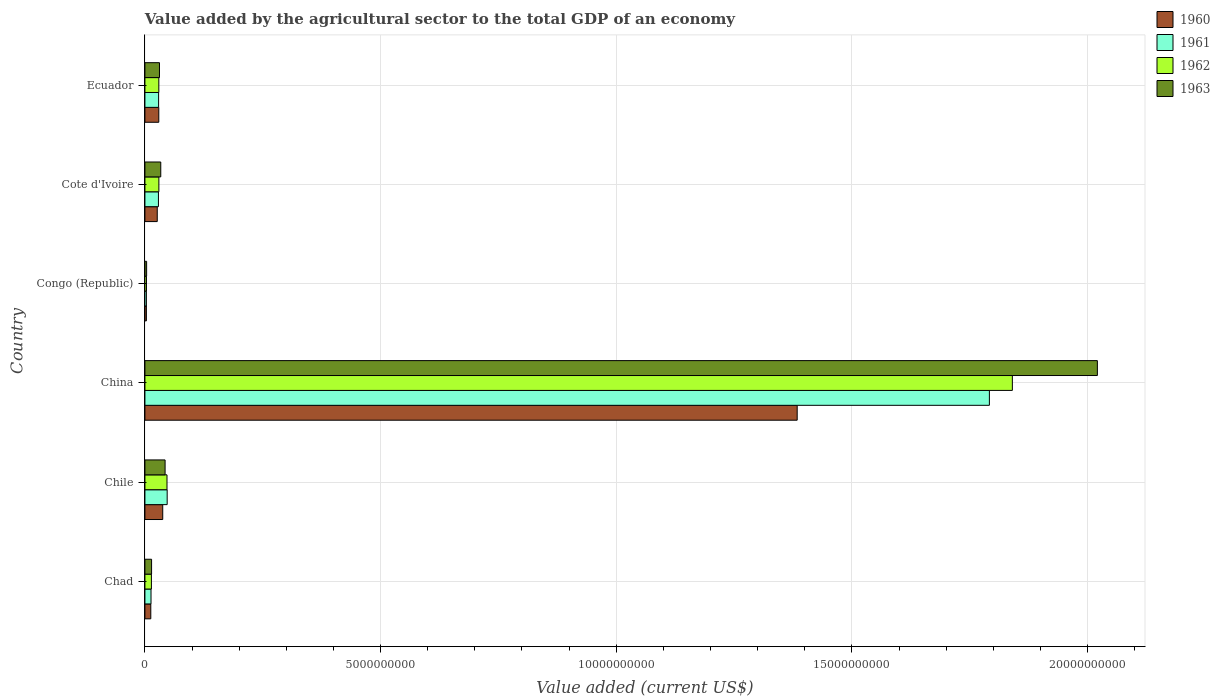How many groups of bars are there?
Your response must be concise. 6. Are the number of bars per tick equal to the number of legend labels?
Your response must be concise. Yes. Are the number of bars on each tick of the Y-axis equal?
Provide a short and direct response. Yes. What is the label of the 4th group of bars from the top?
Provide a succinct answer. China. What is the value added by the agricultural sector to the total GDP in 1963 in Chad?
Ensure brevity in your answer.  1.41e+08. Across all countries, what is the maximum value added by the agricultural sector to the total GDP in 1962?
Provide a succinct answer. 1.84e+1. Across all countries, what is the minimum value added by the agricultural sector to the total GDP in 1960?
Your answer should be very brief. 3.11e+07. In which country was the value added by the agricultural sector to the total GDP in 1960 maximum?
Your answer should be very brief. China. In which country was the value added by the agricultural sector to the total GDP in 1960 minimum?
Ensure brevity in your answer.  Congo (Republic). What is the total value added by the agricultural sector to the total GDP in 1962 in the graph?
Keep it short and to the point. 1.96e+1. What is the difference between the value added by the agricultural sector to the total GDP in 1962 in Chad and that in Congo (Republic)?
Provide a succinct answer. 1.05e+08. What is the difference between the value added by the agricultural sector to the total GDP in 1963 in Chad and the value added by the agricultural sector to the total GDP in 1961 in Congo (Republic)?
Your answer should be very brief. 1.10e+08. What is the average value added by the agricultural sector to the total GDP in 1961 per country?
Ensure brevity in your answer.  3.19e+09. What is the difference between the value added by the agricultural sector to the total GDP in 1961 and value added by the agricultural sector to the total GDP in 1960 in Chad?
Your answer should be compact. 4.82e+06. In how many countries, is the value added by the agricultural sector to the total GDP in 1962 greater than 19000000000 US$?
Offer a terse response. 0. What is the ratio of the value added by the agricultural sector to the total GDP in 1961 in Chile to that in Congo (Republic)?
Your response must be concise. 15.19. Is the value added by the agricultural sector to the total GDP in 1962 in Chile less than that in Ecuador?
Your answer should be very brief. No. Is the difference between the value added by the agricultural sector to the total GDP in 1961 in Chad and Cote d'Ivoire greater than the difference between the value added by the agricultural sector to the total GDP in 1960 in Chad and Cote d'Ivoire?
Offer a terse response. No. What is the difference between the highest and the second highest value added by the agricultural sector to the total GDP in 1962?
Make the answer very short. 1.79e+1. What is the difference between the highest and the lowest value added by the agricultural sector to the total GDP in 1963?
Keep it short and to the point. 2.02e+1. In how many countries, is the value added by the agricultural sector to the total GDP in 1960 greater than the average value added by the agricultural sector to the total GDP in 1960 taken over all countries?
Give a very brief answer. 1. What does the 4th bar from the bottom in Cote d'Ivoire represents?
Ensure brevity in your answer.  1963. How many bars are there?
Your response must be concise. 24. Are all the bars in the graph horizontal?
Keep it short and to the point. Yes. How many countries are there in the graph?
Keep it short and to the point. 6. What is the title of the graph?
Keep it short and to the point. Value added by the agricultural sector to the total GDP of an economy. Does "1999" appear as one of the legend labels in the graph?
Your answer should be very brief. No. What is the label or title of the X-axis?
Your response must be concise. Value added (current US$). What is the Value added (current US$) of 1960 in Chad?
Keep it short and to the point. 1.25e+08. What is the Value added (current US$) of 1961 in Chad?
Keep it short and to the point. 1.29e+08. What is the Value added (current US$) of 1962 in Chad?
Your answer should be compact. 1.38e+08. What is the Value added (current US$) in 1963 in Chad?
Your answer should be compact. 1.41e+08. What is the Value added (current US$) in 1960 in Chile?
Give a very brief answer. 3.78e+08. What is the Value added (current US$) in 1961 in Chile?
Provide a succinct answer. 4.72e+08. What is the Value added (current US$) of 1962 in Chile?
Give a very brief answer. 4.69e+08. What is the Value added (current US$) of 1963 in Chile?
Make the answer very short. 4.28e+08. What is the Value added (current US$) of 1960 in China?
Your answer should be very brief. 1.38e+1. What is the Value added (current US$) of 1961 in China?
Keep it short and to the point. 1.79e+1. What is the Value added (current US$) of 1962 in China?
Provide a succinct answer. 1.84e+1. What is the Value added (current US$) of 1963 in China?
Your answer should be compact. 2.02e+1. What is the Value added (current US$) in 1960 in Congo (Republic)?
Your answer should be compact. 3.11e+07. What is the Value added (current US$) in 1961 in Congo (Republic)?
Provide a succinct answer. 3.11e+07. What is the Value added (current US$) of 1962 in Congo (Republic)?
Ensure brevity in your answer.  3.30e+07. What is the Value added (current US$) in 1963 in Congo (Republic)?
Ensure brevity in your answer.  3.61e+07. What is the Value added (current US$) in 1960 in Cote d'Ivoire?
Give a very brief answer. 2.62e+08. What is the Value added (current US$) in 1961 in Cote d'Ivoire?
Provide a short and direct response. 2.87e+08. What is the Value added (current US$) in 1962 in Cote d'Ivoire?
Your answer should be very brief. 2.96e+08. What is the Value added (current US$) in 1963 in Cote d'Ivoire?
Your answer should be compact. 3.36e+08. What is the Value added (current US$) of 1960 in Ecuador?
Offer a very short reply. 2.94e+08. What is the Value added (current US$) in 1961 in Ecuador?
Offer a very short reply. 2.91e+08. What is the Value added (current US$) of 1962 in Ecuador?
Your answer should be very brief. 2.95e+08. What is the Value added (current US$) of 1963 in Ecuador?
Provide a succinct answer. 3.09e+08. Across all countries, what is the maximum Value added (current US$) in 1960?
Provide a succinct answer. 1.38e+1. Across all countries, what is the maximum Value added (current US$) of 1961?
Ensure brevity in your answer.  1.79e+1. Across all countries, what is the maximum Value added (current US$) of 1962?
Your response must be concise. 1.84e+1. Across all countries, what is the maximum Value added (current US$) of 1963?
Provide a succinct answer. 2.02e+1. Across all countries, what is the minimum Value added (current US$) in 1960?
Provide a short and direct response. 3.11e+07. Across all countries, what is the minimum Value added (current US$) in 1961?
Offer a terse response. 3.11e+07. Across all countries, what is the minimum Value added (current US$) of 1962?
Make the answer very short. 3.30e+07. Across all countries, what is the minimum Value added (current US$) in 1963?
Keep it short and to the point. 3.61e+07. What is the total Value added (current US$) in 1960 in the graph?
Your answer should be very brief. 1.49e+1. What is the total Value added (current US$) of 1961 in the graph?
Provide a short and direct response. 1.91e+1. What is the total Value added (current US$) in 1962 in the graph?
Offer a very short reply. 1.96e+1. What is the total Value added (current US$) of 1963 in the graph?
Keep it short and to the point. 2.15e+1. What is the difference between the Value added (current US$) of 1960 in Chad and that in Chile?
Offer a very short reply. -2.54e+08. What is the difference between the Value added (current US$) in 1961 in Chad and that in Chile?
Your answer should be very brief. -3.43e+08. What is the difference between the Value added (current US$) in 1962 in Chad and that in Chile?
Keep it short and to the point. -3.31e+08. What is the difference between the Value added (current US$) of 1963 in Chad and that in Chile?
Offer a terse response. -2.87e+08. What is the difference between the Value added (current US$) in 1960 in Chad and that in China?
Your response must be concise. -1.37e+1. What is the difference between the Value added (current US$) in 1961 in Chad and that in China?
Offer a very short reply. -1.78e+1. What is the difference between the Value added (current US$) of 1962 in Chad and that in China?
Provide a succinct answer. -1.83e+1. What is the difference between the Value added (current US$) in 1963 in Chad and that in China?
Your answer should be very brief. -2.01e+1. What is the difference between the Value added (current US$) of 1960 in Chad and that in Congo (Republic)?
Give a very brief answer. 9.35e+07. What is the difference between the Value added (current US$) in 1961 in Chad and that in Congo (Republic)?
Your response must be concise. 9.83e+07. What is the difference between the Value added (current US$) in 1962 in Chad and that in Congo (Republic)?
Keep it short and to the point. 1.05e+08. What is the difference between the Value added (current US$) of 1963 in Chad and that in Congo (Republic)?
Your answer should be very brief. 1.05e+08. What is the difference between the Value added (current US$) of 1960 in Chad and that in Cote d'Ivoire?
Provide a short and direct response. -1.37e+08. What is the difference between the Value added (current US$) in 1961 in Chad and that in Cote d'Ivoire?
Ensure brevity in your answer.  -1.58e+08. What is the difference between the Value added (current US$) in 1962 in Chad and that in Cote d'Ivoire?
Your response must be concise. -1.59e+08. What is the difference between the Value added (current US$) in 1963 in Chad and that in Cote d'Ivoire?
Offer a very short reply. -1.95e+08. What is the difference between the Value added (current US$) in 1960 in Chad and that in Ecuador?
Give a very brief answer. -1.70e+08. What is the difference between the Value added (current US$) of 1961 in Chad and that in Ecuador?
Provide a succinct answer. -1.61e+08. What is the difference between the Value added (current US$) in 1962 in Chad and that in Ecuador?
Ensure brevity in your answer.  -1.58e+08. What is the difference between the Value added (current US$) of 1963 in Chad and that in Ecuador?
Keep it short and to the point. -1.68e+08. What is the difference between the Value added (current US$) in 1960 in Chile and that in China?
Keep it short and to the point. -1.35e+1. What is the difference between the Value added (current US$) in 1961 in Chile and that in China?
Ensure brevity in your answer.  -1.74e+1. What is the difference between the Value added (current US$) in 1962 in Chile and that in China?
Your answer should be very brief. -1.79e+1. What is the difference between the Value added (current US$) of 1963 in Chile and that in China?
Your answer should be compact. -1.98e+1. What is the difference between the Value added (current US$) of 1960 in Chile and that in Congo (Republic)?
Your response must be concise. 3.47e+08. What is the difference between the Value added (current US$) of 1961 in Chile and that in Congo (Republic)?
Your answer should be compact. 4.41e+08. What is the difference between the Value added (current US$) in 1962 in Chile and that in Congo (Republic)?
Keep it short and to the point. 4.36e+08. What is the difference between the Value added (current US$) in 1963 in Chile and that in Congo (Republic)?
Provide a short and direct response. 3.92e+08. What is the difference between the Value added (current US$) of 1960 in Chile and that in Cote d'Ivoire?
Give a very brief answer. 1.16e+08. What is the difference between the Value added (current US$) in 1961 in Chile and that in Cote d'Ivoire?
Your answer should be very brief. 1.85e+08. What is the difference between the Value added (current US$) of 1962 in Chile and that in Cote d'Ivoire?
Keep it short and to the point. 1.72e+08. What is the difference between the Value added (current US$) of 1963 in Chile and that in Cote d'Ivoire?
Keep it short and to the point. 9.18e+07. What is the difference between the Value added (current US$) of 1960 in Chile and that in Ecuador?
Your answer should be very brief. 8.36e+07. What is the difference between the Value added (current US$) of 1961 in Chile and that in Ecuador?
Give a very brief answer. 1.82e+08. What is the difference between the Value added (current US$) in 1962 in Chile and that in Ecuador?
Your response must be concise. 1.73e+08. What is the difference between the Value added (current US$) of 1963 in Chile and that in Ecuador?
Provide a short and direct response. 1.19e+08. What is the difference between the Value added (current US$) of 1960 in China and that in Congo (Republic)?
Keep it short and to the point. 1.38e+1. What is the difference between the Value added (current US$) of 1961 in China and that in Congo (Republic)?
Your response must be concise. 1.79e+1. What is the difference between the Value added (current US$) of 1962 in China and that in Congo (Republic)?
Provide a short and direct response. 1.84e+1. What is the difference between the Value added (current US$) of 1963 in China and that in Congo (Republic)?
Give a very brief answer. 2.02e+1. What is the difference between the Value added (current US$) in 1960 in China and that in Cote d'Ivoire?
Provide a short and direct response. 1.36e+1. What is the difference between the Value added (current US$) in 1961 in China and that in Cote d'Ivoire?
Keep it short and to the point. 1.76e+1. What is the difference between the Value added (current US$) in 1962 in China and that in Cote d'Ivoire?
Provide a succinct answer. 1.81e+1. What is the difference between the Value added (current US$) of 1963 in China and that in Cote d'Ivoire?
Offer a terse response. 1.99e+1. What is the difference between the Value added (current US$) of 1960 in China and that in Ecuador?
Your answer should be compact. 1.35e+1. What is the difference between the Value added (current US$) of 1961 in China and that in Ecuador?
Provide a short and direct response. 1.76e+1. What is the difference between the Value added (current US$) in 1962 in China and that in Ecuador?
Provide a short and direct response. 1.81e+1. What is the difference between the Value added (current US$) of 1963 in China and that in Ecuador?
Your answer should be compact. 1.99e+1. What is the difference between the Value added (current US$) in 1960 in Congo (Republic) and that in Cote d'Ivoire?
Your answer should be very brief. -2.31e+08. What is the difference between the Value added (current US$) of 1961 in Congo (Republic) and that in Cote d'Ivoire?
Offer a terse response. -2.56e+08. What is the difference between the Value added (current US$) of 1962 in Congo (Republic) and that in Cote d'Ivoire?
Keep it short and to the point. -2.63e+08. What is the difference between the Value added (current US$) in 1963 in Congo (Republic) and that in Cote d'Ivoire?
Make the answer very short. -3.00e+08. What is the difference between the Value added (current US$) of 1960 in Congo (Republic) and that in Ecuador?
Your response must be concise. -2.63e+08. What is the difference between the Value added (current US$) of 1961 in Congo (Republic) and that in Ecuador?
Provide a succinct answer. -2.59e+08. What is the difference between the Value added (current US$) in 1962 in Congo (Republic) and that in Ecuador?
Provide a short and direct response. -2.62e+08. What is the difference between the Value added (current US$) in 1963 in Congo (Republic) and that in Ecuador?
Offer a terse response. -2.73e+08. What is the difference between the Value added (current US$) in 1960 in Cote d'Ivoire and that in Ecuador?
Provide a succinct answer. -3.28e+07. What is the difference between the Value added (current US$) in 1961 in Cote d'Ivoire and that in Ecuador?
Offer a very short reply. -3.61e+06. What is the difference between the Value added (current US$) in 1962 in Cote d'Ivoire and that in Ecuador?
Make the answer very short. 1.03e+06. What is the difference between the Value added (current US$) of 1963 in Cote d'Ivoire and that in Ecuador?
Provide a short and direct response. 2.70e+07. What is the difference between the Value added (current US$) of 1960 in Chad and the Value added (current US$) of 1961 in Chile?
Give a very brief answer. -3.48e+08. What is the difference between the Value added (current US$) in 1960 in Chad and the Value added (current US$) in 1962 in Chile?
Your answer should be compact. -3.44e+08. What is the difference between the Value added (current US$) of 1960 in Chad and the Value added (current US$) of 1963 in Chile?
Give a very brief answer. -3.03e+08. What is the difference between the Value added (current US$) in 1961 in Chad and the Value added (current US$) in 1962 in Chile?
Give a very brief answer. -3.39e+08. What is the difference between the Value added (current US$) in 1961 in Chad and the Value added (current US$) in 1963 in Chile?
Keep it short and to the point. -2.99e+08. What is the difference between the Value added (current US$) in 1962 in Chad and the Value added (current US$) in 1963 in Chile?
Your response must be concise. -2.90e+08. What is the difference between the Value added (current US$) in 1960 in Chad and the Value added (current US$) in 1961 in China?
Offer a very short reply. -1.78e+1. What is the difference between the Value added (current US$) in 1960 in Chad and the Value added (current US$) in 1962 in China?
Your response must be concise. -1.83e+1. What is the difference between the Value added (current US$) of 1960 in Chad and the Value added (current US$) of 1963 in China?
Your answer should be very brief. -2.01e+1. What is the difference between the Value added (current US$) of 1961 in Chad and the Value added (current US$) of 1962 in China?
Make the answer very short. -1.83e+1. What is the difference between the Value added (current US$) of 1961 in Chad and the Value added (current US$) of 1963 in China?
Offer a very short reply. -2.01e+1. What is the difference between the Value added (current US$) in 1962 in Chad and the Value added (current US$) in 1963 in China?
Provide a short and direct response. -2.01e+1. What is the difference between the Value added (current US$) of 1960 in Chad and the Value added (current US$) of 1961 in Congo (Republic)?
Your answer should be very brief. 9.35e+07. What is the difference between the Value added (current US$) in 1960 in Chad and the Value added (current US$) in 1962 in Congo (Republic)?
Offer a very short reply. 9.16e+07. What is the difference between the Value added (current US$) in 1960 in Chad and the Value added (current US$) in 1963 in Congo (Republic)?
Ensure brevity in your answer.  8.85e+07. What is the difference between the Value added (current US$) in 1961 in Chad and the Value added (current US$) in 1962 in Congo (Republic)?
Keep it short and to the point. 9.64e+07. What is the difference between the Value added (current US$) of 1961 in Chad and the Value added (current US$) of 1963 in Congo (Republic)?
Offer a terse response. 9.33e+07. What is the difference between the Value added (current US$) of 1962 in Chad and the Value added (current US$) of 1963 in Congo (Republic)?
Your answer should be very brief. 1.02e+08. What is the difference between the Value added (current US$) in 1960 in Chad and the Value added (current US$) in 1961 in Cote d'Ivoire?
Provide a short and direct response. -1.62e+08. What is the difference between the Value added (current US$) of 1960 in Chad and the Value added (current US$) of 1962 in Cote d'Ivoire?
Offer a terse response. -1.72e+08. What is the difference between the Value added (current US$) of 1960 in Chad and the Value added (current US$) of 1963 in Cote d'Ivoire?
Give a very brief answer. -2.12e+08. What is the difference between the Value added (current US$) in 1961 in Chad and the Value added (current US$) in 1962 in Cote d'Ivoire?
Ensure brevity in your answer.  -1.67e+08. What is the difference between the Value added (current US$) of 1961 in Chad and the Value added (current US$) of 1963 in Cote d'Ivoire?
Make the answer very short. -2.07e+08. What is the difference between the Value added (current US$) in 1962 in Chad and the Value added (current US$) in 1963 in Cote d'Ivoire?
Give a very brief answer. -1.99e+08. What is the difference between the Value added (current US$) of 1960 in Chad and the Value added (current US$) of 1961 in Ecuador?
Your answer should be compact. -1.66e+08. What is the difference between the Value added (current US$) in 1960 in Chad and the Value added (current US$) in 1962 in Ecuador?
Provide a short and direct response. -1.71e+08. What is the difference between the Value added (current US$) in 1960 in Chad and the Value added (current US$) in 1963 in Ecuador?
Keep it short and to the point. -1.85e+08. What is the difference between the Value added (current US$) of 1961 in Chad and the Value added (current US$) of 1962 in Ecuador?
Give a very brief answer. -1.66e+08. What is the difference between the Value added (current US$) of 1961 in Chad and the Value added (current US$) of 1963 in Ecuador?
Provide a succinct answer. -1.80e+08. What is the difference between the Value added (current US$) of 1962 in Chad and the Value added (current US$) of 1963 in Ecuador?
Provide a short and direct response. -1.72e+08. What is the difference between the Value added (current US$) in 1960 in Chile and the Value added (current US$) in 1961 in China?
Provide a short and direct response. -1.75e+1. What is the difference between the Value added (current US$) in 1960 in Chile and the Value added (current US$) in 1962 in China?
Your answer should be compact. -1.80e+1. What is the difference between the Value added (current US$) of 1960 in Chile and the Value added (current US$) of 1963 in China?
Your answer should be very brief. -1.98e+1. What is the difference between the Value added (current US$) in 1961 in Chile and the Value added (current US$) in 1962 in China?
Offer a terse response. -1.79e+1. What is the difference between the Value added (current US$) of 1961 in Chile and the Value added (current US$) of 1963 in China?
Offer a very short reply. -1.97e+1. What is the difference between the Value added (current US$) in 1962 in Chile and the Value added (current US$) in 1963 in China?
Offer a terse response. -1.97e+1. What is the difference between the Value added (current US$) in 1960 in Chile and the Value added (current US$) in 1961 in Congo (Republic)?
Ensure brevity in your answer.  3.47e+08. What is the difference between the Value added (current US$) in 1960 in Chile and the Value added (current US$) in 1962 in Congo (Republic)?
Offer a very short reply. 3.45e+08. What is the difference between the Value added (current US$) of 1960 in Chile and the Value added (current US$) of 1963 in Congo (Republic)?
Offer a very short reply. 3.42e+08. What is the difference between the Value added (current US$) in 1961 in Chile and the Value added (current US$) in 1962 in Congo (Republic)?
Your answer should be very brief. 4.39e+08. What is the difference between the Value added (current US$) in 1961 in Chile and the Value added (current US$) in 1963 in Congo (Republic)?
Offer a terse response. 4.36e+08. What is the difference between the Value added (current US$) of 1962 in Chile and the Value added (current US$) of 1963 in Congo (Republic)?
Give a very brief answer. 4.33e+08. What is the difference between the Value added (current US$) of 1960 in Chile and the Value added (current US$) of 1961 in Cote d'Ivoire?
Your answer should be compact. 9.12e+07. What is the difference between the Value added (current US$) in 1960 in Chile and the Value added (current US$) in 1962 in Cote d'Ivoire?
Make the answer very short. 8.19e+07. What is the difference between the Value added (current US$) of 1960 in Chile and the Value added (current US$) of 1963 in Cote d'Ivoire?
Ensure brevity in your answer.  4.20e+07. What is the difference between the Value added (current US$) of 1961 in Chile and the Value added (current US$) of 1962 in Cote d'Ivoire?
Your response must be concise. 1.76e+08. What is the difference between the Value added (current US$) of 1961 in Chile and the Value added (current US$) of 1963 in Cote d'Ivoire?
Make the answer very short. 1.36e+08. What is the difference between the Value added (current US$) of 1962 in Chile and the Value added (current US$) of 1963 in Cote d'Ivoire?
Offer a terse response. 1.32e+08. What is the difference between the Value added (current US$) in 1960 in Chile and the Value added (current US$) in 1961 in Ecuador?
Your response must be concise. 8.76e+07. What is the difference between the Value added (current US$) of 1960 in Chile and the Value added (current US$) of 1962 in Ecuador?
Offer a very short reply. 8.29e+07. What is the difference between the Value added (current US$) in 1960 in Chile and the Value added (current US$) in 1963 in Ecuador?
Provide a short and direct response. 6.90e+07. What is the difference between the Value added (current US$) in 1961 in Chile and the Value added (current US$) in 1962 in Ecuador?
Provide a succinct answer. 1.77e+08. What is the difference between the Value added (current US$) of 1961 in Chile and the Value added (current US$) of 1963 in Ecuador?
Offer a terse response. 1.63e+08. What is the difference between the Value added (current US$) of 1962 in Chile and the Value added (current US$) of 1963 in Ecuador?
Make the answer very short. 1.59e+08. What is the difference between the Value added (current US$) of 1960 in China and the Value added (current US$) of 1961 in Congo (Republic)?
Your response must be concise. 1.38e+1. What is the difference between the Value added (current US$) in 1960 in China and the Value added (current US$) in 1962 in Congo (Republic)?
Provide a succinct answer. 1.38e+1. What is the difference between the Value added (current US$) in 1960 in China and the Value added (current US$) in 1963 in Congo (Republic)?
Ensure brevity in your answer.  1.38e+1. What is the difference between the Value added (current US$) of 1961 in China and the Value added (current US$) of 1962 in Congo (Republic)?
Your answer should be very brief. 1.79e+1. What is the difference between the Value added (current US$) of 1961 in China and the Value added (current US$) of 1963 in Congo (Republic)?
Give a very brief answer. 1.79e+1. What is the difference between the Value added (current US$) in 1962 in China and the Value added (current US$) in 1963 in Congo (Republic)?
Offer a very short reply. 1.84e+1. What is the difference between the Value added (current US$) in 1960 in China and the Value added (current US$) in 1961 in Cote d'Ivoire?
Offer a very short reply. 1.36e+1. What is the difference between the Value added (current US$) in 1960 in China and the Value added (current US$) in 1962 in Cote d'Ivoire?
Your answer should be very brief. 1.35e+1. What is the difference between the Value added (current US$) of 1960 in China and the Value added (current US$) of 1963 in Cote d'Ivoire?
Provide a short and direct response. 1.35e+1. What is the difference between the Value added (current US$) in 1961 in China and the Value added (current US$) in 1962 in Cote d'Ivoire?
Make the answer very short. 1.76e+1. What is the difference between the Value added (current US$) of 1961 in China and the Value added (current US$) of 1963 in Cote d'Ivoire?
Offer a very short reply. 1.76e+1. What is the difference between the Value added (current US$) in 1962 in China and the Value added (current US$) in 1963 in Cote d'Ivoire?
Your response must be concise. 1.81e+1. What is the difference between the Value added (current US$) in 1960 in China and the Value added (current US$) in 1961 in Ecuador?
Ensure brevity in your answer.  1.35e+1. What is the difference between the Value added (current US$) in 1960 in China and the Value added (current US$) in 1962 in Ecuador?
Provide a short and direct response. 1.35e+1. What is the difference between the Value added (current US$) of 1960 in China and the Value added (current US$) of 1963 in Ecuador?
Provide a short and direct response. 1.35e+1. What is the difference between the Value added (current US$) of 1961 in China and the Value added (current US$) of 1962 in Ecuador?
Your answer should be very brief. 1.76e+1. What is the difference between the Value added (current US$) of 1961 in China and the Value added (current US$) of 1963 in Ecuador?
Make the answer very short. 1.76e+1. What is the difference between the Value added (current US$) in 1962 in China and the Value added (current US$) in 1963 in Ecuador?
Ensure brevity in your answer.  1.81e+1. What is the difference between the Value added (current US$) of 1960 in Congo (Republic) and the Value added (current US$) of 1961 in Cote d'Ivoire?
Your answer should be compact. -2.56e+08. What is the difference between the Value added (current US$) of 1960 in Congo (Republic) and the Value added (current US$) of 1962 in Cote d'Ivoire?
Make the answer very short. -2.65e+08. What is the difference between the Value added (current US$) of 1960 in Congo (Republic) and the Value added (current US$) of 1963 in Cote d'Ivoire?
Offer a very short reply. -3.05e+08. What is the difference between the Value added (current US$) of 1961 in Congo (Republic) and the Value added (current US$) of 1962 in Cote d'Ivoire?
Offer a terse response. -2.65e+08. What is the difference between the Value added (current US$) of 1961 in Congo (Republic) and the Value added (current US$) of 1963 in Cote d'Ivoire?
Your answer should be compact. -3.05e+08. What is the difference between the Value added (current US$) of 1962 in Congo (Republic) and the Value added (current US$) of 1963 in Cote d'Ivoire?
Ensure brevity in your answer.  -3.03e+08. What is the difference between the Value added (current US$) in 1960 in Congo (Republic) and the Value added (current US$) in 1961 in Ecuador?
Offer a terse response. -2.59e+08. What is the difference between the Value added (current US$) in 1960 in Congo (Republic) and the Value added (current US$) in 1962 in Ecuador?
Your answer should be compact. -2.64e+08. What is the difference between the Value added (current US$) of 1960 in Congo (Republic) and the Value added (current US$) of 1963 in Ecuador?
Your answer should be compact. -2.78e+08. What is the difference between the Value added (current US$) in 1961 in Congo (Republic) and the Value added (current US$) in 1962 in Ecuador?
Make the answer very short. -2.64e+08. What is the difference between the Value added (current US$) of 1961 in Congo (Republic) and the Value added (current US$) of 1963 in Ecuador?
Offer a terse response. -2.78e+08. What is the difference between the Value added (current US$) of 1962 in Congo (Republic) and the Value added (current US$) of 1963 in Ecuador?
Offer a terse response. -2.76e+08. What is the difference between the Value added (current US$) of 1960 in Cote d'Ivoire and the Value added (current US$) of 1961 in Ecuador?
Give a very brief answer. -2.88e+07. What is the difference between the Value added (current US$) of 1960 in Cote d'Ivoire and the Value added (current US$) of 1962 in Ecuador?
Offer a terse response. -3.35e+07. What is the difference between the Value added (current US$) in 1960 in Cote d'Ivoire and the Value added (current US$) in 1963 in Ecuador?
Ensure brevity in your answer.  -4.74e+07. What is the difference between the Value added (current US$) of 1961 in Cote d'Ivoire and the Value added (current US$) of 1962 in Ecuador?
Make the answer very short. -8.28e+06. What is the difference between the Value added (current US$) in 1961 in Cote d'Ivoire and the Value added (current US$) in 1963 in Ecuador?
Ensure brevity in your answer.  -2.22e+07. What is the difference between the Value added (current US$) of 1962 in Cote d'Ivoire and the Value added (current US$) of 1963 in Ecuador?
Offer a very short reply. -1.29e+07. What is the average Value added (current US$) of 1960 per country?
Provide a succinct answer. 2.49e+09. What is the average Value added (current US$) of 1961 per country?
Make the answer very short. 3.19e+09. What is the average Value added (current US$) in 1962 per country?
Offer a terse response. 3.27e+09. What is the average Value added (current US$) of 1963 per country?
Your answer should be compact. 3.58e+09. What is the difference between the Value added (current US$) in 1960 and Value added (current US$) in 1961 in Chad?
Provide a short and direct response. -4.82e+06. What is the difference between the Value added (current US$) of 1960 and Value added (current US$) of 1962 in Chad?
Offer a very short reply. -1.30e+07. What is the difference between the Value added (current US$) in 1960 and Value added (current US$) in 1963 in Chad?
Make the answer very short. -1.68e+07. What is the difference between the Value added (current US$) of 1961 and Value added (current US$) of 1962 in Chad?
Offer a very short reply. -8.22e+06. What is the difference between the Value added (current US$) in 1961 and Value added (current US$) in 1963 in Chad?
Offer a very short reply. -1.20e+07. What is the difference between the Value added (current US$) in 1962 and Value added (current US$) in 1963 in Chad?
Provide a succinct answer. -3.78e+06. What is the difference between the Value added (current US$) of 1960 and Value added (current US$) of 1961 in Chile?
Offer a terse response. -9.41e+07. What is the difference between the Value added (current US$) of 1960 and Value added (current US$) of 1962 in Chile?
Offer a very short reply. -9.05e+07. What is the difference between the Value added (current US$) of 1960 and Value added (current US$) of 1963 in Chile?
Provide a short and direct response. -4.98e+07. What is the difference between the Value added (current US$) in 1961 and Value added (current US$) in 1962 in Chile?
Offer a terse response. 3.57e+06. What is the difference between the Value added (current US$) in 1961 and Value added (current US$) in 1963 in Chile?
Ensure brevity in your answer.  4.42e+07. What is the difference between the Value added (current US$) of 1962 and Value added (current US$) of 1963 in Chile?
Make the answer very short. 4.07e+07. What is the difference between the Value added (current US$) in 1960 and Value added (current US$) in 1961 in China?
Provide a succinct answer. -4.08e+09. What is the difference between the Value added (current US$) in 1960 and Value added (current US$) in 1962 in China?
Provide a succinct answer. -4.57e+09. What is the difference between the Value added (current US$) in 1960 and Value added (current US$) in 1963 in China?
Your response must be concise. -6.37e+09. What is the difference between the Value added (current US$) in 1961 and Value added (current US$) in 1962 in China?
Offer a terse response. -4.87e+08. What is the difference between the Value added (current US$) of 1961 and Value added (current US$) of 1963 in China?
Keep it short and to the point. -2.29e+09. What is the difference between the Value added (current US$) of 1962 and Value added (current US$) of 1963 in China?
Give a very brief answer. -1.80e+09. What is the difference between the Value added (current US$) in 1960 and Value added (current US$) in 1961 in Congo (Republic)?
Give a very brief answer. 8239.47. What is the difference between the Value added (current US$) of 1960 and Value added (current US$) of 1962 in Congo (Republic)?
Ensure brevity in your answer.  -1.89e+06. What is the difference between the Value added (current US$) of 1960 and Value added (current US$) of 1963 in Congo (Republic)?
Keep it short and to the point. -5.00e+06. What is the difference between the Value added (current US$) of 1961 and Value added (current US$) of 1962 in Congo (Republic)?
Make the answer very short. -1.90e+06. What is the difference between the Value added (current US$) in 1961 and Value added (current US$) in 1963 in Congo (Republic)?
Keep it short and to the point. -5.01e+06. What is the difference between the Value added (current US$) of 1962 and Value added (current US$) of 1963 in Congo (Republic)?
Give a very brief answer. -3.11e+06. What is the difference between the Value added (current US$) in 1960 and Value added (current US$) in 1961 in Cote d'Ivoire?
Provide a short and direct response. -2.52e+07. What is the difference between the Value added (current US$) of 1960 and Value added (current US$) of 1962 in Cote d'Ivoire?
Make the answer very short. -3.45e+07. What is the difference between the Value added (current US$) of 1960 and Value added (current US$) of 1963 in Cote d'Ivoire?
Provide a short and direct response. -7.45e+07. What is the difference between the Value added (current US$) in 1961 and Value added (current US$) in 1962 in Cote d'Ivoire?
Your response must be concise. -9.30e+06. What is the difference between the Value added (current US$) in 1961 and Value added (current US$) in 1963 in Cote d'Ivoire?
Provide a short and direct response. -4.92e+07. What is the difference between the Value added (current US$) in 1962 and Value added (current US$) in 1963 in Cote d'Ivoire?
Give a very brief answer. -3.99e+07. What is the difference between the Value added (current US$) in 1960 and Value added (current US$) in 1961 in Ecuador?
Your response must be concise. 3.96e+06. What is the difference between the Value added (current US$) in 1960 and Value added (current US$) in 1962 in Ecuador?
Offer a very short reply. -6.97e+05. What is the difference between the Value added (current US$) of 1960 and Value added (current US$) of 1963 in Ecuador?
Your answer should be very brief. -1.46e+07. What is the difference between the Value added (current US$) of 1961 and Value added (current US$) of 1962 in Ecuador?
Your answer should be very brief. -4.66e+06. What is the difference between the Value added (current US$) of 1961 and Value added (current US$) of 1963 in Ecuador?
Provide a succinct answer. -1.86e+07. What is the difference between the Value added (current US$) in 1962 and Value added (current US$) in 1963 in Ecuador?
Ensure brevity in your answer.  -1.39e+07. What is the ratio of the Value added (current US$) of 1960 in Chad to that in Chile?
Offer a very short reply. 0.33. What is the ratio of the Value added (current US$) of 1961 in Chad to that in Chile?
Keep it short and to the point. 0.27. What is the ratio of the Value added (current US$) in 1962 in Chad to that in Chile?
Offer a terse response. 0.29. What is the ratio of the Value added (current US$) in 1963 in Chad to that in Chile?
Make the answer very short. 0.33. What is the ratio of the Value added (current US$) of 1960 in Chad to that in China?
Provide a short and direct response. 0.01. What is the ratio of the Value added (current US$) in 1961 in Chad to that in China?
Provide a short and direct response. 0.01. What is the ratio of the Value added (current US$) of 1962 in Chad to that in China?
Keep it short and to the point. 0.01. What is the ratio of the Value added (current US$) in 1963 in Chad to that in China?
Provide a short and direct response. 0.01. What is the ratio of the Value added (current US$) in 1960 in Chad to that in Congo (Republic)?
Ensure brevity in your answer.  4.01. What is the ratio of the Value added (current US$) of 1961 in Chad to that in Congo (Republic)?
Your answer should be very brief. 4.16. What is the ratio of the Value added (current US$) in 1962 in Chad to that in Congo (Republic)?
Offer a terse response. 4.17. What is the ratio of the Value added (current US$) in 1963 in Chad to that in Congo (Republic)?
Your response must be concise. 3.92. What is the ratio of the Value added (current US$) of 1960 in Chad to that in Cote d'Ivoire?
Make the answer very short. 0.48. What is the ratio of the Value added (current US$) in 1961 in Chad to that in Cote d'Ivoire?
Your response must be concise. 0.45. What is the ratio of the Value added (current US$) in 1962 in Chad to that in Cote d'Ivoire?
Offer a very short reply. 0.46. What is the ratio of the Value added (current US$) of 1963 in Chad to that in Cote d'Ivoire?
Your response must be concise. 0.42. What is the ratio of the Value added (current US$) in 1960 in Chad to that in Ecuador?
Make the answer very short. 0.42. What is the ratio of the Value added (current US$) in 1961 in Chad to that in Ecuador?
Make the answer very short. 0.45. What is the ratio of the Value added (current US$) in 1962 in Chad to that in Ecuador?
Provide a short and direct response. 0.47. What is the ratio of the Value added (current US$) of 1963 in Chad to that in Ecuador?
Your answer should be very brief. 0.46. What is the ratio of the Value added (current US$) of 1960 in Chile to that in China?
Offer a terse response. 0.03. What is the ratio of the Value added (current US$) of 1961 in Chile to that in China?
Provide a succinct answer. 0.03. What is the ratio of the Value added (current US$) of 1962 in Chile to that in China?
Your answer should be compact. 0.03. What is the ratio of the Value added (current US$) of 1963 in Chile to that in China?
Keep it short and to the point. 0.02. What is the ratio of the Value added (current US$) of 1960 in Chile to that in Congo (Republic)?
Offer a terse response. 12.16. What is the ratio of the Value added (current US$) in 1961 in Chile to that in Congo (Republic)?
Offer a very short reply. 15.19. What is the ratio of the Value added (current US$) in 1962 in Chile to that in Congo (Republic)?
Offer a terse response. 14.21. What is the ratio of the Value added (current US$) of 1963 in Chile to that in Congo (Republic)?
Keep it short and to the point. 11.86. What is the ratio of the Value added (current US$) of 1960 in Chile to that in Cote d'Ivoire?
Provide a succinct answer. 1.44. What is the ratio of the Value added (current US$) of 1961 in Chile to that in Cote d'Ivoire?
Offer a very short reply. 1.65. What is the ratio of the Value added (current US$) of 1962 in Chile to that in Cote d'Ivoire?
Provide a short and direct response. 1.58. What is the ratio of the Value added (current US$) in 1963 in Chile to that in Cote d'Ivoire?
Your answer should be very brief. 1.27. What is the ratio of the Value added (current US$) in 1960 in Chile to that in Ecuador?
Your answer should be very brief. 1.28. What is the ratio of the Value added (current US$) in 1961 in Chile to that in Ecuador?
Your response must be concise. 1.63. What is the ratio of the Value added (current US$) in 1962 in Chile to that in Ecuador?
Your response must be concise. 1.59. What is the ratio of the Value added (current US$) in 1963 in Chile to that in Ecuador?
Make the answer very short. 1.38. What is the ratio of the Value added (current US$) of 1960 in China to that in Congo (Republic)?
Make the answer very short. 445.15. What is the ratio of the Value added (current US$) in 1961 in China to that in Congo (Republic)?
Offer a terse response. 576.48. What is the ratio of the Value added (current US$) in 1962 in China to that in Congo (Republic)?
Provide a short and direct response. 558.09. What is the ratio of the Value added (current US$) of 1963 in China to that in Congo (Republic)?
Provide a succinct answer. 559.95. What is the ratio of the Value added (current US$) in 1960 in China to that in Cote d'Ivoire?
Your answer should be compact. 52.89. What is the ratio of the Value added (current US$) of 1961 in China to that in Cote d'Ivoire?
Your response must be concise. 62.45. What is the ratio of the Value added (current US$) in 1962 in China to that in Cote d'Ivoire?
Provide a succinct answer. 62.14. What is the ratio of the Value added (current US$) in 1963 in China to that in Cote d'Ivoire?
Provide a succinct answer. 60.12. What is the ratio of the Value added (current US$) in 1960 in China to that in Ecuador?
Offer a terse response. 47. What is the ratio of the Value added (current US$) in 1961 in China to that in Ecuador?
Offer a terse response. 61.67. What is the ratio of the Value added (current US$) in 1962 in China to that in Ecuador?
Your answer should be compact. 62.35. What is the ratio of the Value added (current US$) in 1963 in China to that in Ecuador?
Provide a succinct answer. 65.37. What is the ratio of the Value added (current US$) in 1960 in Congo (Republic) to that in Cote d'Ivoire?
Provide a succinct answer. 0.12. What is the ratio of the Value added (current US$) in 1961 in Congo (Republic) to that in Cote d'Ivoire?
Provide a succinct answer. 0.11. What is the ratio of the Value added (current US$) of 1962 in Congo (Republic) to that in Cote d'Ivoire?
Provide a short and direct response. 0.11. What is the ratio of the Value added (current US$) in 1963 in Congo (Republic) to that in Cote d'Ivoire?
Offer a terse response. 0.11. What is the ratio of the Value added (current US$) of 1960 in Congo (Republic) to that in Ecuador?
Keep it short and to the point. 0.11. What is the ratio of the Value added (current US$) in 1961 in Congo (Republic) to that in Ecuador?
Provide a short and direct response. 0.11. What is the ratio of the Value added (current US$) of 1962 in Congo (Republic) to that in Ecuador?
Give a very brief answer. 0.11. What is the ratio of the Value added (current US$) in 1963 in Congo (Republic) to that in Ecuador?
Your answer should be compact. 0.12. What is the ratio of the Value added (current US$) of 1960 in Cote d'Ivoire to that in Ecuador?
Offer a terse response. 0.89. What is the ratio of the Value added (current US$) in 1961 in Cote d'Ivoire to that in Ecuador?
Give a very brief answer. 0.99. What is the ratio of the Value added (current US$) of 1963 in Cote d'Ivoire to that in Ecuador?
Give a very brief answer. 1.09. What is the difference between the highest and the second highest Value added (current US$) of 1960?
Your answer should be very brief. 1.35e+1. What is the difference between the highest and the second highest Value added (current US$) of 1961?
Keep it short and to the point. 1.74e+1. What is the difference between the highest and the second highest Value added (current US$) of 1962?
Keep it short and to the point. 1.79e+1. What is the difference between the highest and the second highest Value added (current US$) of 1963?
Keep it short and to the point. 1.98e+1. What is the difference between the highest and the lowest Value added (current US$) in 1960?
Make the answer very short. 1.38e+1. What is the difference between the highest and the lowest Value added (current US$) of 1961?
Your response must be concise. 1.79e+1. What is the difference between the highest and the lowest Value added (current US$) in 1962?
Ensure brevity in your answer.  1.84e+1. What is the difference between the highest and the lowest Value added (current US$) in 1963?
Offer a very short reply. 2.02e+1. 